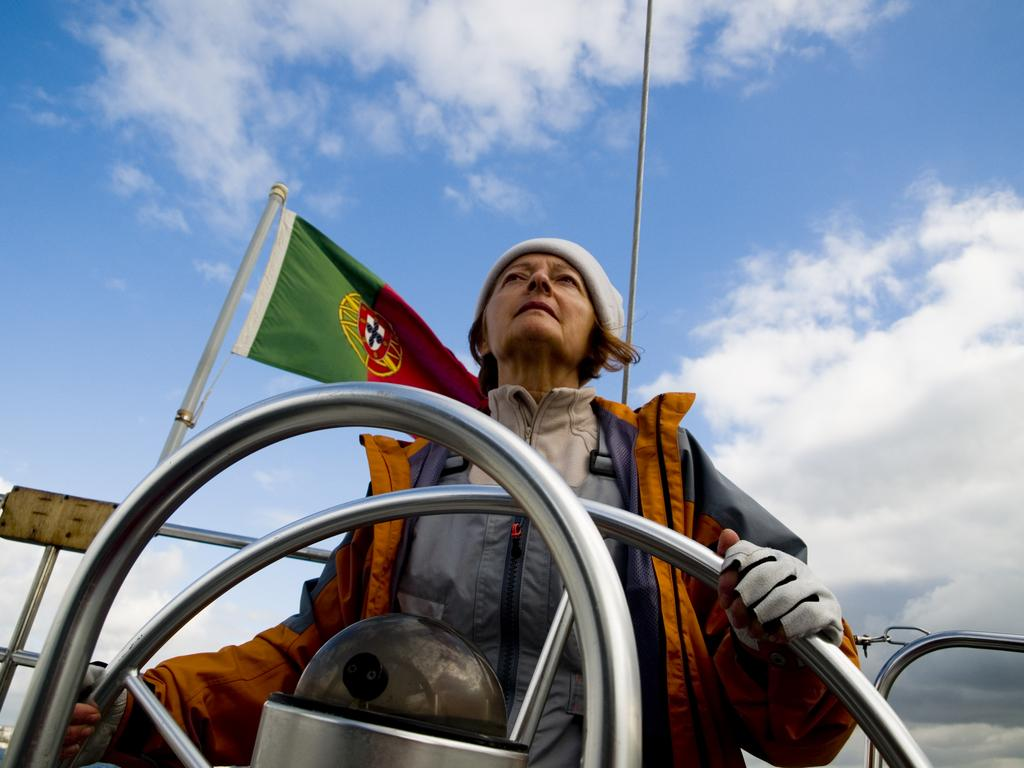Who is the main subject in the image? There is a woman in the image. What is the woman holding in the image? The woman is holding a wheel. Where is the flag located in the image? The flag is on the left side of the image. How would you describe the sky in the image? The sky is blue and cloudy. What type of fruit can be seen hanging from the wheel in the image? There is no fruit hanging from the wheel in the image. Can you see a tramp performing tricks in the image? There is no tramp performing tricks in the image. 